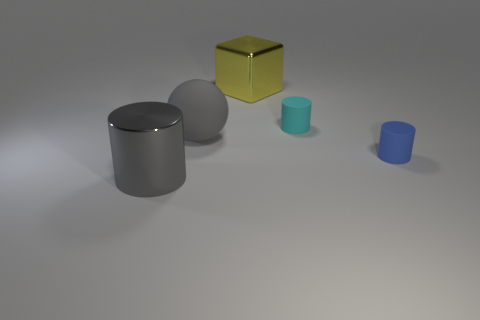Add 1 small blue rubber spheres. How many objects exist? 6 Subtract all cylinders. How many objects are left? 2 Add 5 large gray cylinders. How many large gray cylinders exist? 6 Subtract 0 yellow spheres. How many objects are left? 5 Subtract all gray rubber things. Subtract all big metallic objects. How many objects are left? 2 Add 4 tiny blue matte cylinders. How many tiny blue matte cylinders are left? 5 